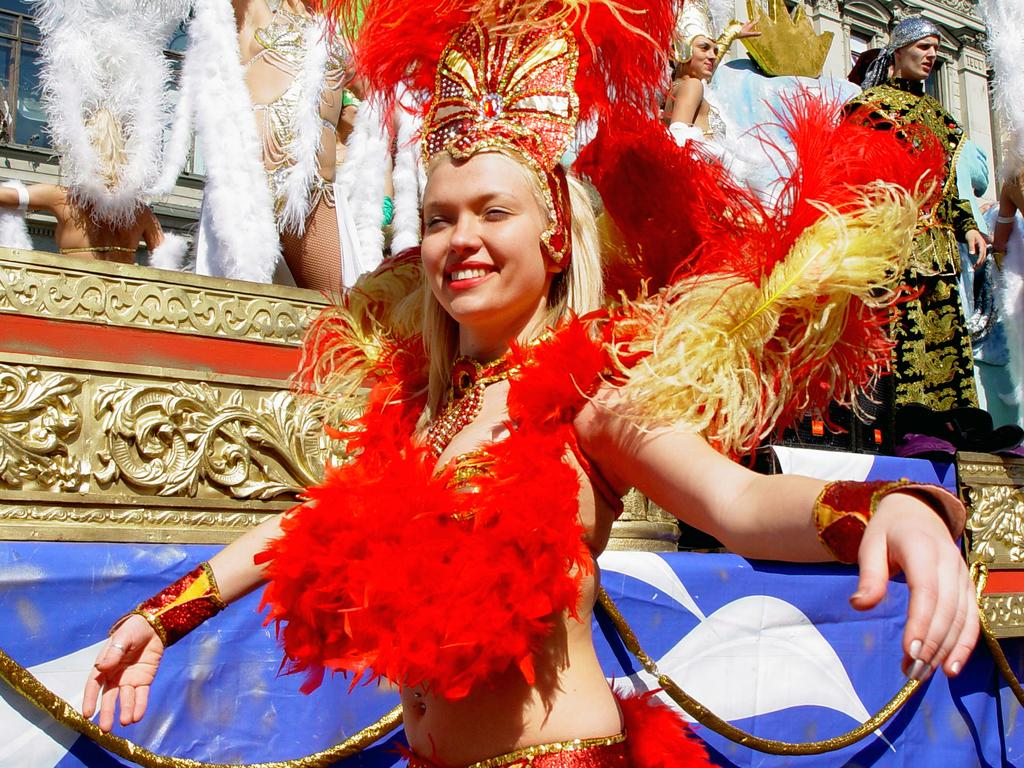Who is the main subject in the image? There is a woman in the image. What is the woman wearing? The woman is wearing a costume. What is the woman doing in the image? The woman is standing and smiling. Can you describe the background of the image? There are people visible in the background of the image. What type of growth can be seen on the side of the woman in the image? There is no growth visible on the woman in the image; she is wearing a costume. What does the woman represent in the image? The image does not provide any information about what the woman might represent. 